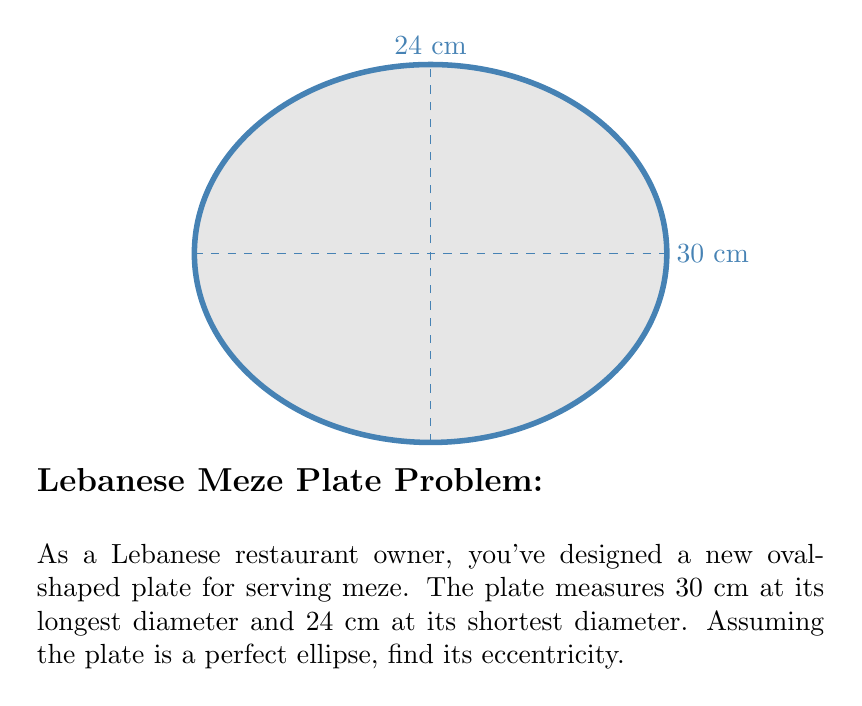Solve this math problem. Let's approach this step-by-step:

1) For an ellipse, eccentricity (e) is given by the formula:

   $$e = \sqrt{1 - \frac{b^2}{a^2}}$$

   where $a$ is the semi-major axis and $b$ is the semi-minor axis.

2) From the given dimensions:
   - Major axis = 30 cm, so $a = 15$ cm
   - Minor axis = 24 cm, so $b = 12$ cm

3) Substituting these values into the formula:

   $$e = \sqrt{1 - \frac{12^2}{15^2}}$$

4) Simplify inside the square root:
   
   $$e = \sqrt{1 - \frac{144}{225}}$$

5) Perform the division:

   $$e = \sqrt{1 - 0.64}$$

6) Subtract:

   $$e = \sqrt{0.36}$$

7) Take the square root:

   $$e = 0.6$$

Thus, the eccentricity of the oval-shaped plate is 0.6.
Answer: $0.6$ 